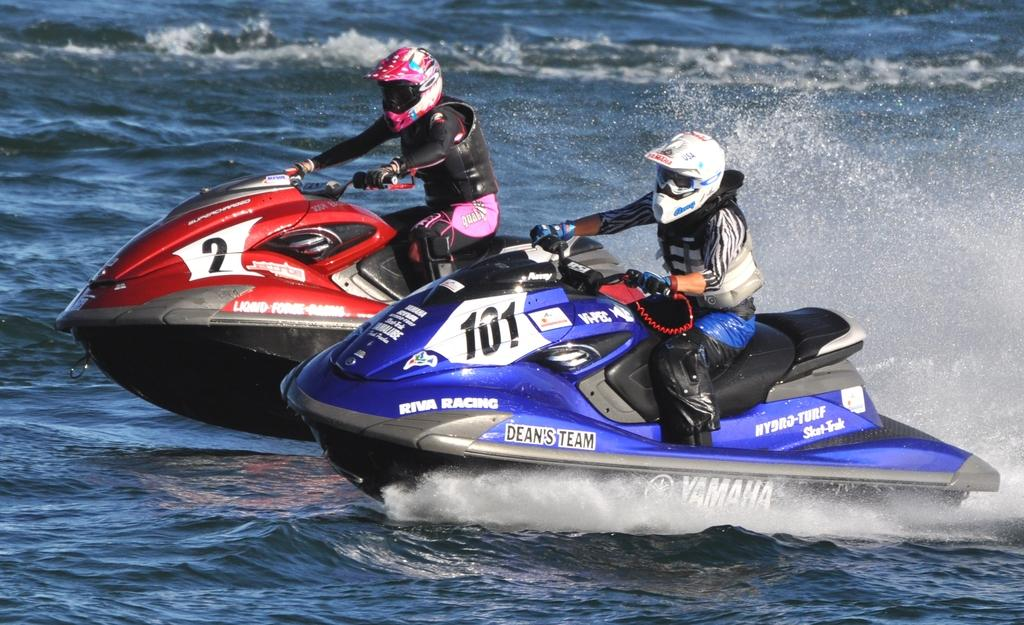How many people are in the image? There are two people in the image. What are the people doing in the image? The people are on jet skis. Where are the jet skis located in the image? The jet skis are in the center of the image. What is the primary setting of the image? There is water visible in the image. What type of tray is being used by the people on the jet skis in the image? There is no tray present in the image; the people are riding jet skis in the water. 